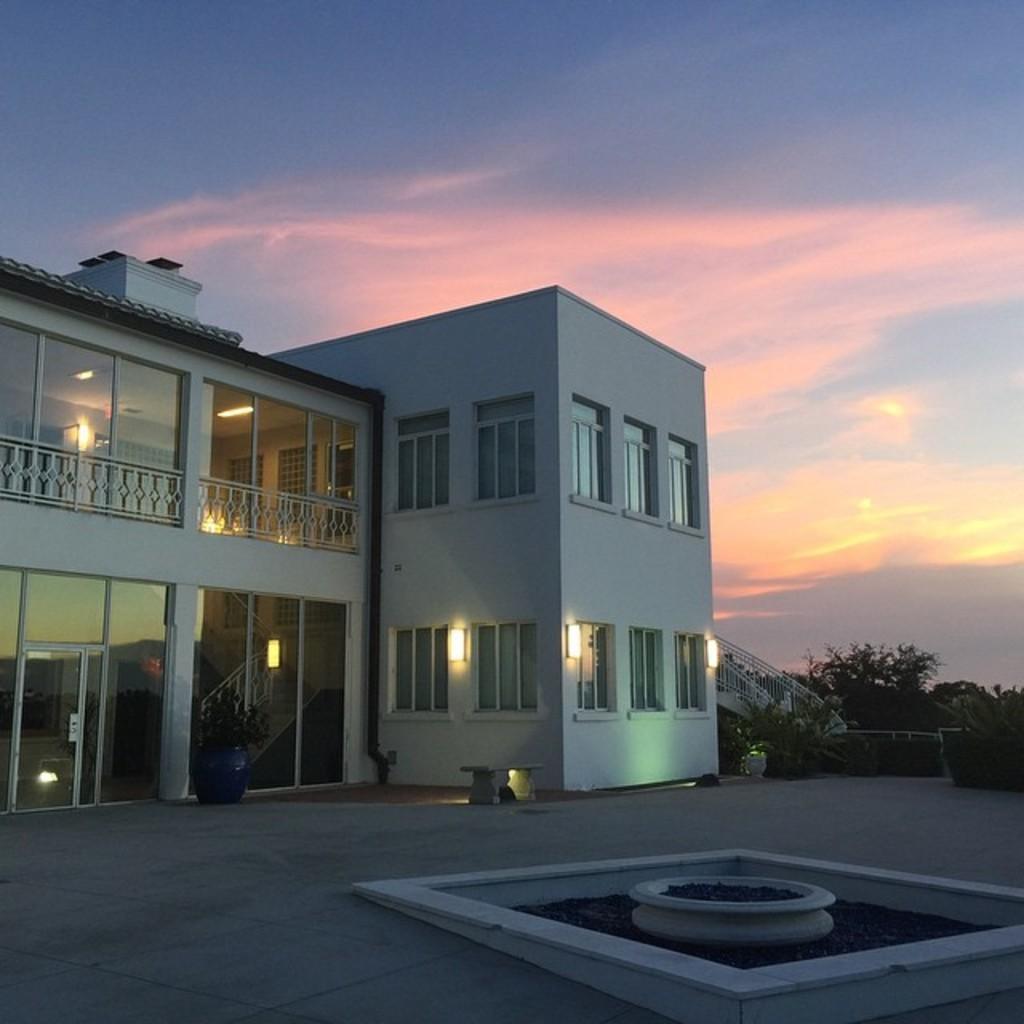Please provide a concise description of this image. On left there is a building. Here we can see windows, doors and fencing. On the bottom right there is a fountain block. On the right background we can see stairs and many trees. On the top we can see sky and clouds. 